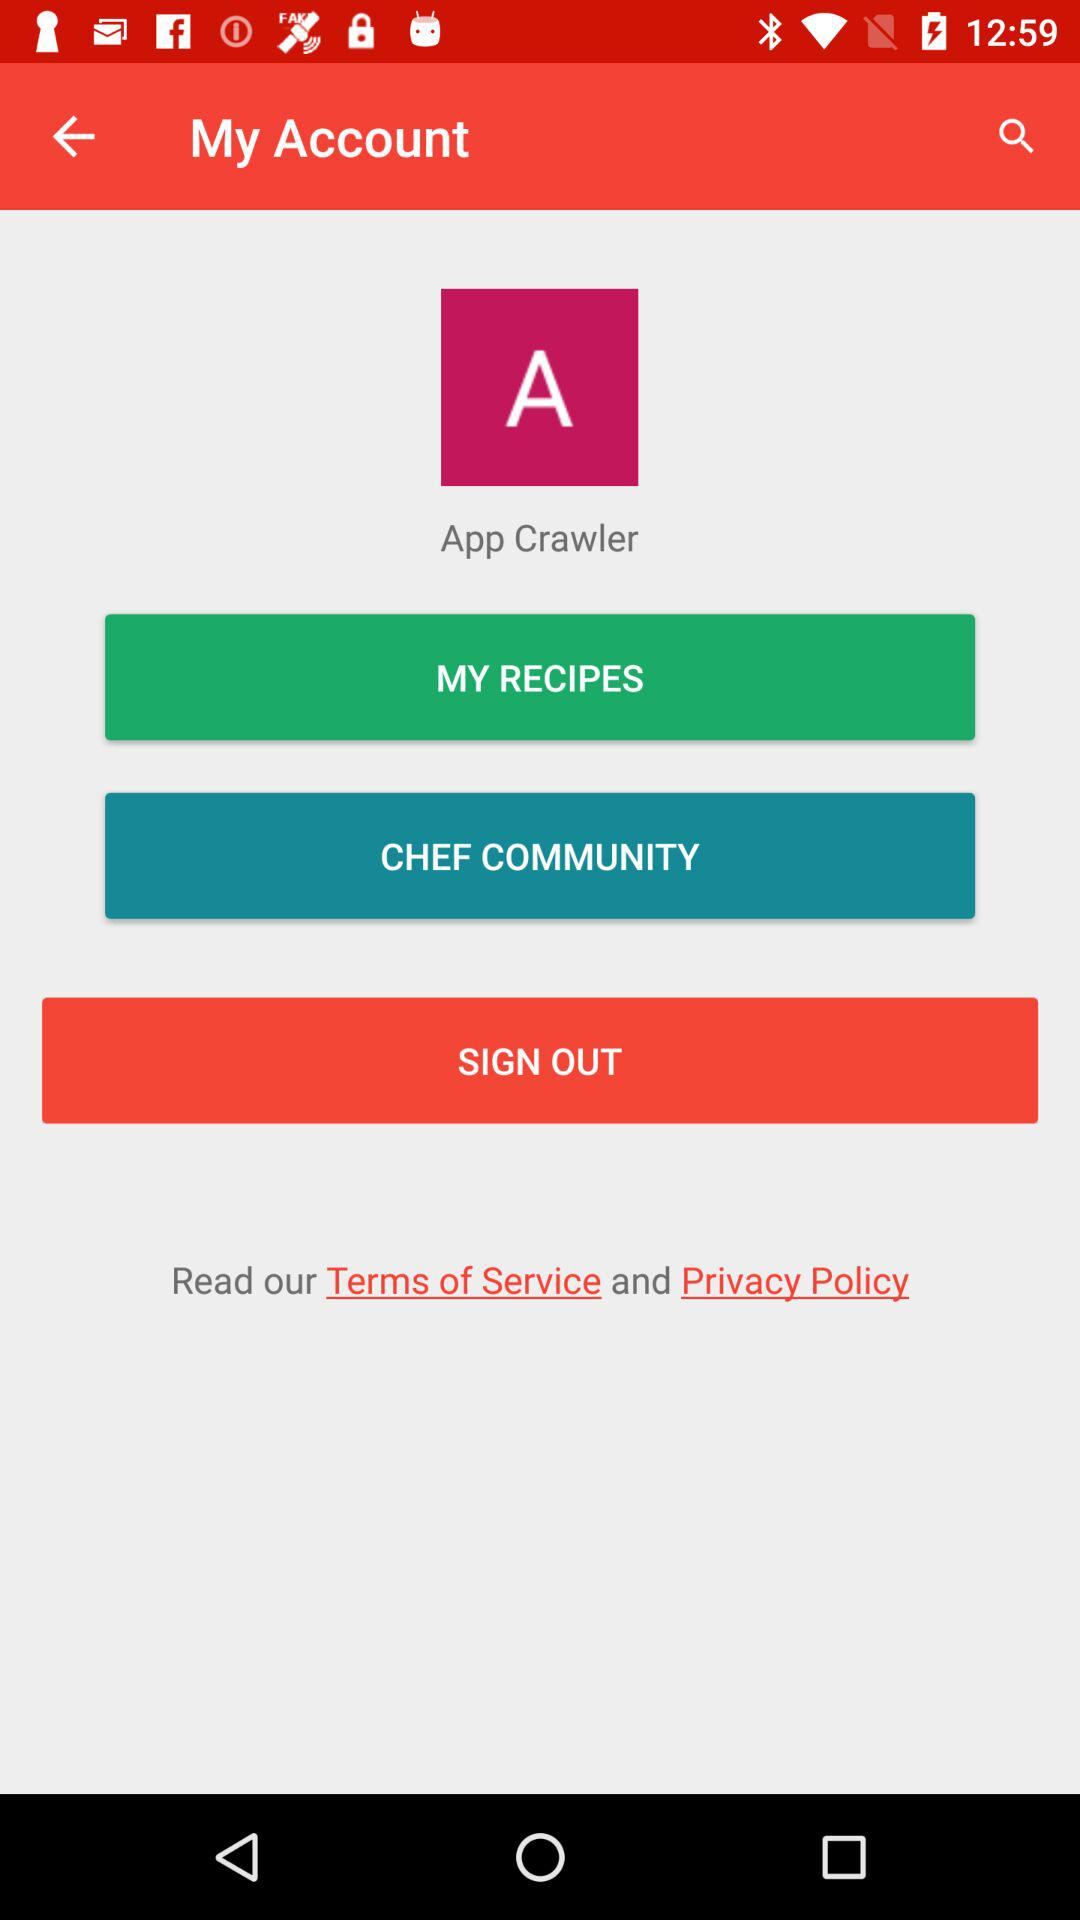What is the user name? The user name is App Crawler. 